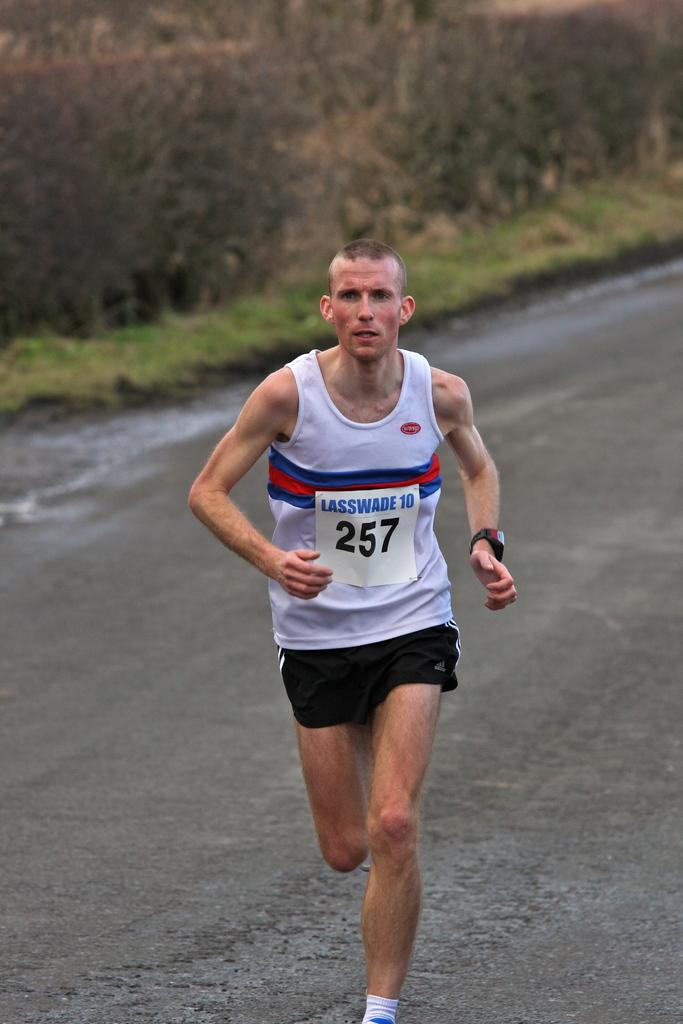<image>
Relay a brief, clear account of the picture shown. a person running with the number 257 on their jersey 